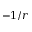<formula> <loc_0><loc_0><loc_500><loc_500>- 1 / r</formula> 